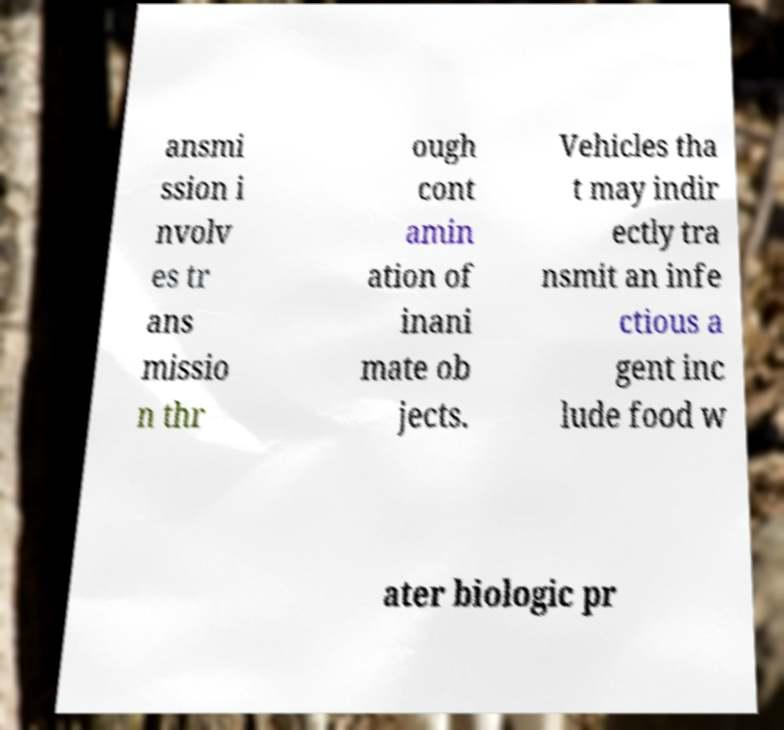I need the written content from this picture converted into text. Can you do that? ansmi ssion i nvolv es tr ans missio n thr ough cont amin ation of inani mate ob jects. Vehicles tha t may indir ectly tra nsmit an infe ctious a gent inc lude food w ater biologic pr 